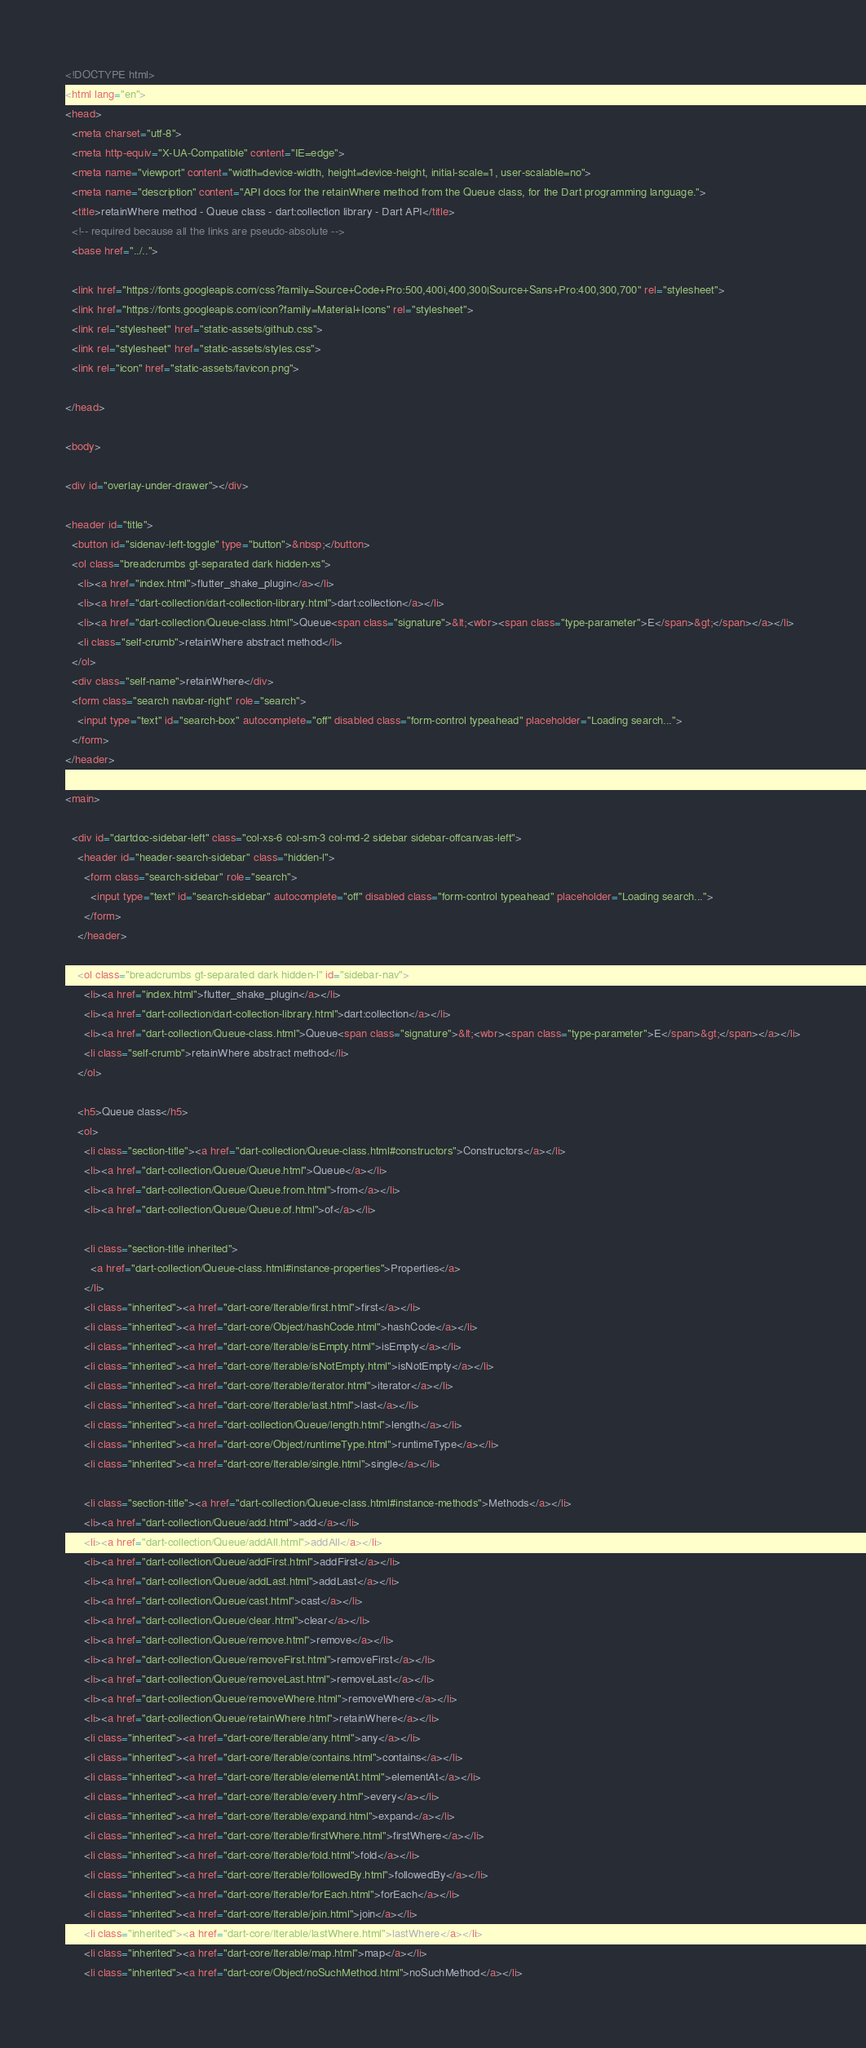Convert code to text. <code><loc_0><loc_0><loc_500><loc_500><_HTML_><!DOCTYPE html>
<html lang="en">
<head>
  <meta charset="utf-8">
  <meta http-equiv="X-UA-Compatible" content="IE=edge">
  <meta name="viewport" content="width=device-width, height=device-height, initial-scale=1, user-scalable=no">
  <meta name="description" content="API docs for the retainWhere method from the Queue class, for the Dart programming language.">
  <title>retainWhere method - Queue class - dart:collection library - Dart API</title>
  <!-- required because all the links are pseudo-absolute -->
  <base href="../..">

  <link href="https://fonts.googleapis.com/css?family=Source+Code+Pro:500,400i,400,300|Source+Sans+Pro:400,300,700" rel="stylesheet">
  <link href="https://fonts.googleapis.com/icon?family=Material+Icons" rel="stylesheet">
  <link rel="stylesheet" href="static-assets/github.css">
  <link rel="stylesheet" href="static-assets/styles.css">
  <link rel="icon" href="static-assets/favicon.png">
  
</head>

<body>

<div id="overlay-under-drawer"></div>

<header id="title">
  <button id="sidenav-left-toggle" type="button">&nbsp;</button>
  <ol class="breadcrumbs gt-separated dark hidden-xs">
    <li><a href="index.html">flutter_shake_plugin</a></li>
    <li><a href="dart-collection/dart-collection-library.html">dart:collection</a></li>
    <li><a href="dart-collection/Queue-class.html">Queue<span class="signature">&lt;<wbr><span class="type-parameter">E</span>&gt;</span></a></li>
    <li class="self-crumb">retainWhere abstract method</li>
  </ol>
  <div class="self-name">retainWhere</div>
  <form class="search navbar-right" role="search">
    <input type="text" id="search-box" autocomplete="off" disabled class="form-control typeahead" placeholder="Loading search...">
  </form>
</header>

<main>

  <div id="dartdoc-sidebar-left" class="col-xs-6 col-sm-3 col-md-2 sidebar sidebar-offcanvas-left">
    <header id="header-search-sidebar" class="hidden-l">
      <form class="search-sidebar" role="search">
        <input type="text" id="search-sidebar" autocomplete="off" disabled class="form-control typeahead" placeholder="Loading search...">
      </form>
    </header>
    
    <ol class="breadcrumbs gt-separated dark hidden-l" id="sidebar-nav">
      <li><a href="index.html">flutter_shake_plugin</a></li>
      <li><a href="dart-collection/dart-collection-library.html">dart:collection</a></li>
      <li><a href="dart-collection/Queue-class.html">Queue<span class="signature">&lt;<wbr><span class="type-parameter">E</span>&gt;</span></a></li>
      <li class="self-crumb">retainWhere abstract method</li>
    </ol>
    
    <h5>Queue class</h5>
    <ol>
      <li class="section-title"><a href="dart-collection/Queue-class.html#constructors">Constructors</a></li>
      <li><a href="dart-collection/Queue/Queue.html">Queue</a></li>
      <li><a href="dart-collection/Queue/Queue.from.html">from</a></li>
      <li><a href="dart-collection/Queue/Queue.of.html">of</a></li>
    
      <li class="section-title inherited">
        <a href="dart-collection/Queue-class.html#instance-properties">Properties</a>
      </li>
      <li class="inherited"><a href="dart-core/Iterable/first.html">first</a></li>
      <li class="inherited"><a href="dart-core/Object/hashCode.html">hashCode</a></li>
      <li class="inherited"><a href="dart-core/Iterable/isEmpty.html">isEmpty</a></li>
      <li class="inherited"><a href="dart-core/Iterable/isNotEmpty.html">isNotEmpty</a></li>
      <li class="inherited"><a href="dart-core/Iterable/iterator.html">iterator</a></li>
      <li class="inherited"><a href="dart-core/Iterable/last.html">last</a></li>
      <li class="inherited"><a href="dart-collection/Queue/length.html">length</a></li>
      <li class="inherited"><a href="dart-core/Object/runtimeType.html">runtimeType</a></li>
      <li class="inherited"><a href="dart-core/Iterable/single.html">single</a></li>
    
      <li class="section-title"><a href="dart-collection/Queue-class.html#instance-methods">Methods</a></li>
      <li><a href="dart-collection/Queue/add.html">add</a></li>
      <li><a href="dart-collection/Queue/addAll.html">addAll</a></li>
      <li><a href="dart-collection/Queue/addFirst.html">addFirst</a></li>
      <li><a href="dart-collection/Queue/addLast.html">addLast</a></li>
      <li><a href="dart-collection/Queue/cast.html">cast</a></li>
      <li><a href="dart-collection/Queue/clear.html">clear</a></li>
      <li><a href="dart-collection/Queue/remove.html">remove</a></li>
      <li><a href="dart-collection/Queue/removeFirst.html">removeFirst</a></li>
      <li><a href="dart-collection/Queue/removeLast.html">removeLast</a></li>
      <li><a href="dart-collection/Queue/removeWhere.html">removeWhere</a></li>
      <li><a href="dart-collection/Queue/retainWhere.html">retainWhere</a></li>
      <li class="inherited"><a href="dart-core/Iterable/any.html">any</a></li>
      <li class="inherited"><a href="dart-core/Iterable/contains.html">contains</a></li>
      <li class="inherited"><a href="dart-core/Iterable/elementAt.html">elementAt</a></li>
      <li class="inherited"><a href="dart-core/Iterable/every.html">every</a></li>
      <li class="inherited"><a href="dart-core/Iterable/expand.html">expand</a></li>
      <li class="inherited"><a href="dart-core/Iterable/firstWhere.html">firstWhere</a></li>
      <li class="inherited"><a href="dart-core/Iterable/fold.html">fold</a></li>
      <li class="inherited"><a href="dart-core/Iterable/followedBy.html">followedBy</a></li>
      <li class="inherited"><a href="dart-core/Iterable/forEach.html">forEach</a></li>
      <li class="inherited"><a href="dart-core/Iterable/join.html">join</a></li>
      <li class="inherited"><a href="dart-core/Iterable/lastWhere.html">lastWhere</a></li>
      <li class="inherited"><a href="dart-core/Iterable/map.html">map</a></li>
      <li class="inherited"><a href="dart-core/Object/noSuchMethod.html">noSuchMethod</a></li></code> 